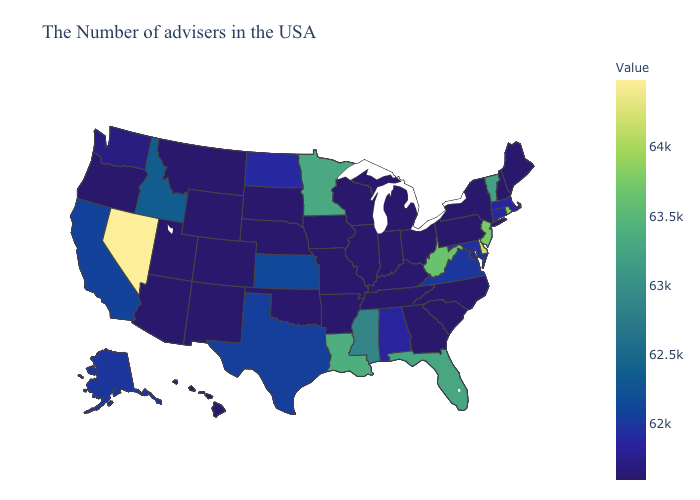Does Colorado have a higher value than Florida?
Write a very short answer. No. Does Minnesota have the highest value in the MidWest?
Short answer required. Yes. Which states have the lowest value in the USA?
Concise answer only. Maine, New Hampshire, New York, Pennsylvania, North Carolina, South Carolina, Ohio, Georgia, Michigan, Indiana, Tennessee, Wisconsin, Illinois, Missouri, Arkansas, Iowa, Nebraska, Oklahoma, South Dakota, Wyoming, Colorado, New Mexico, Utah, Montana, Arizona, Oregon, Hawaii. 